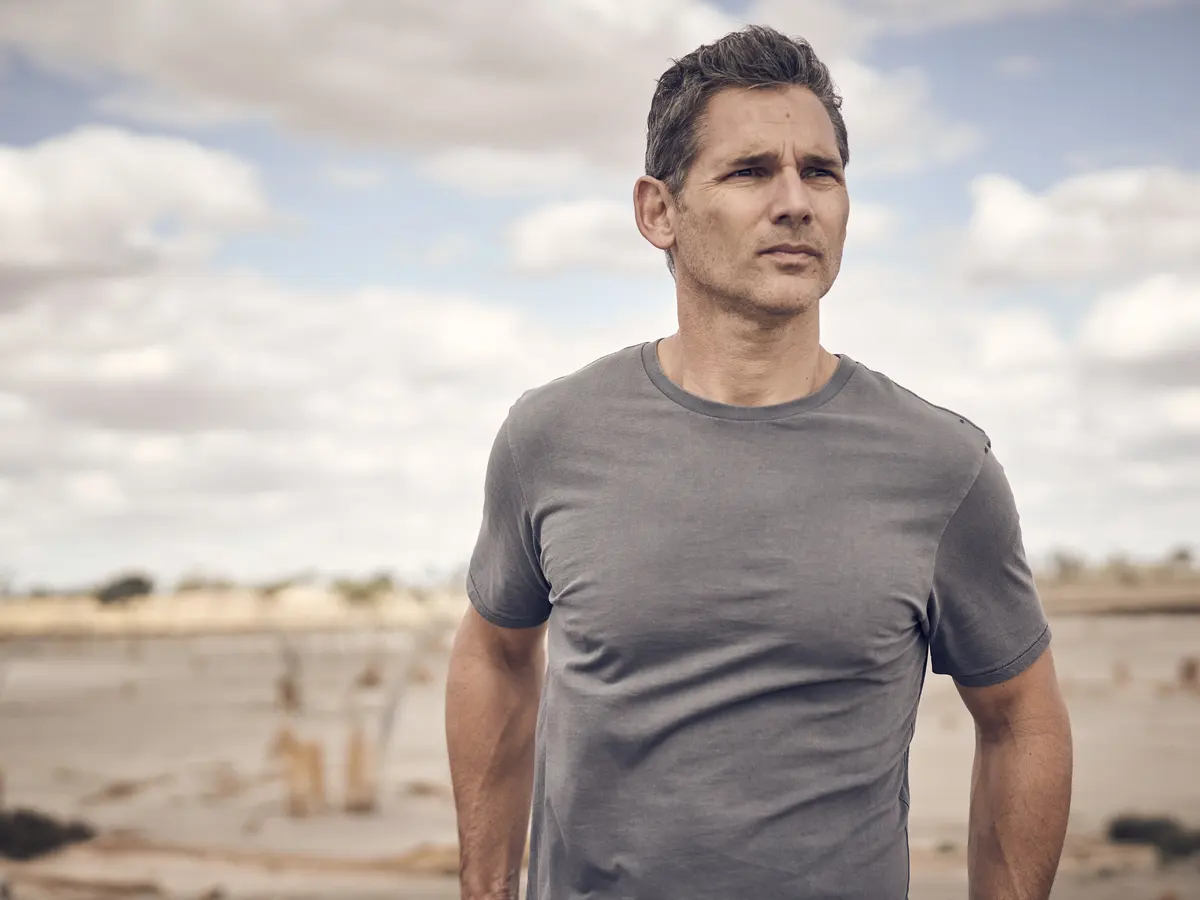Think of an extraordinary question you could ask about this image. If the man in the image could communicate with the clouds above, what wisdom or stories might they share with him about the world and his journey ahead? 